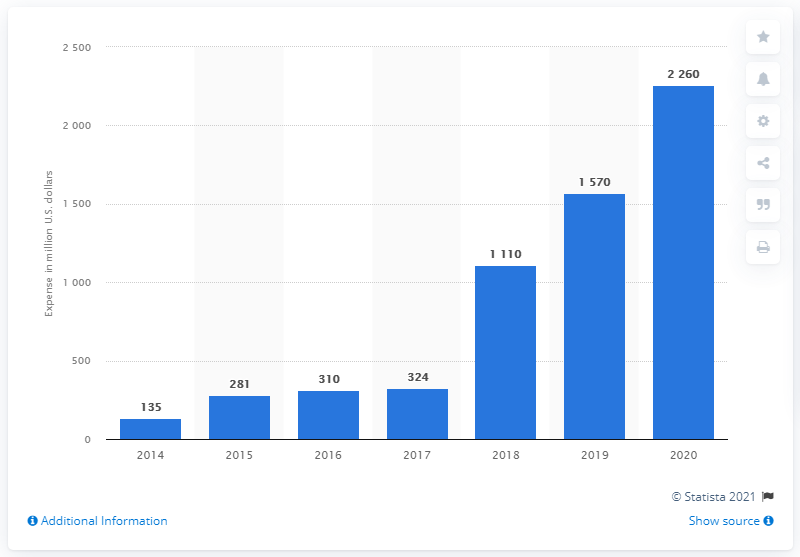Point out several critical features in this image. Facebook's advertising expenses from 2014 to 2020 were approximately $22.6 billion. 